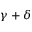Convert formula to latex. <formula><loc_0><loc_0><loc_500><loc_500>\gamma + \delta</formula> 